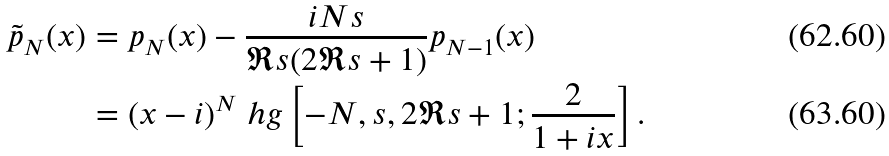<formula> <loc_0><loc_0><loc_500><loc_500>\tilde { p } _ { N } ( x ) & = p _ { N } ( x ) - \frac { i N s } { \Re { s } ( 2 \Re { s } + 1 ) } p _ { N - 1 } ( x ) \\ & = ( x - i ) ^ { N } \ h g \left [ - N , s , 2 \Re { s } + 1 ; \frac { 2 } { 1 + i x } \right ] .</formula> 